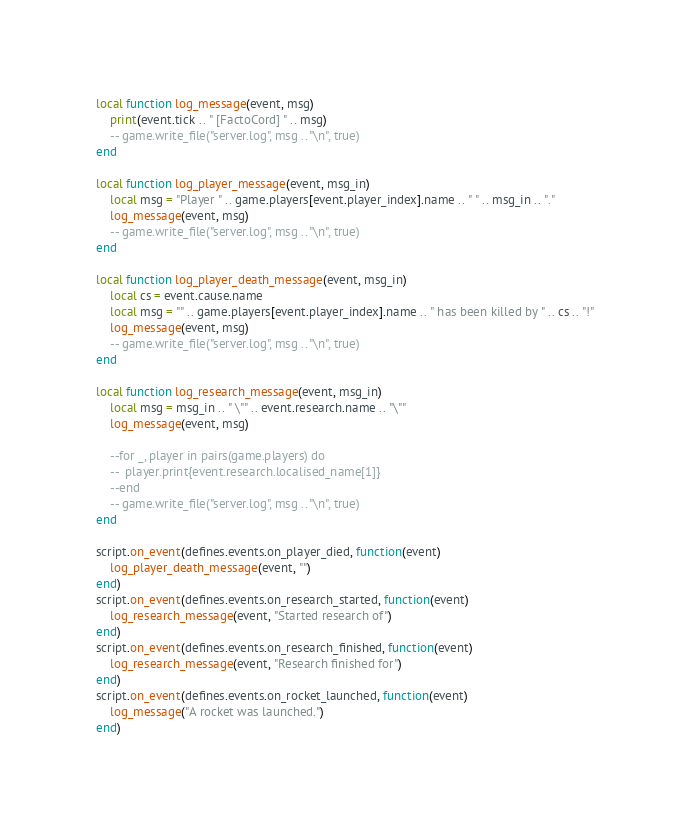<code> <loc_0><loc_0><loc_500><loc_500><_Lua_>local function log_message(event, msg)
    print(event.tick .. " [FactoCord] " .. msg)
    -- game.write_file("server.log", msg .. "\n", true)
end

local function log_player_message(event, msg_in)
    local msg = "Player " .. game.players[event.player_index].name .. " " .. msg_in .. "."
    log_message(event, msg)
    -- game.write_file("server.log", msg .. "\n", true)
end

local function log_player_death_message(event, msg_in)
    local cs = event.cause.name
    local msg = "" .. game.players[event.player_index].name .. " has been killed by " .. cs .. "!"
    log_message(event, msg)
    -- game.write_file("server.log", msg .. "\n", true)
end

local function log_research_message(event, msg_in)
    local msg = msg_in .. " \"" .. event.research.name .. "\""
    log_message(event, msg)

    --for _, player in pairs(game.players) do
    --	player.print{event.research.localised_name[1]}
    --end
    -- game.write_file("server.log", msg .. "\n", true)
end

script.on_event(defines.events.on_player_died, function(event)
    log_player_death_message(event, "")
end)
script.on_event(defines.events.on_research_started, function(event)
    log_research_message(event, "Started research of")
end)
script.on_event(defines.events.on_research_finished, function(event)
    log_research_message(event, "Research finished for")
end)
script.on_event(defines.events.on_rocket_launched, function(event)
    log_message("A rocket was launched.")
end)
</code> 